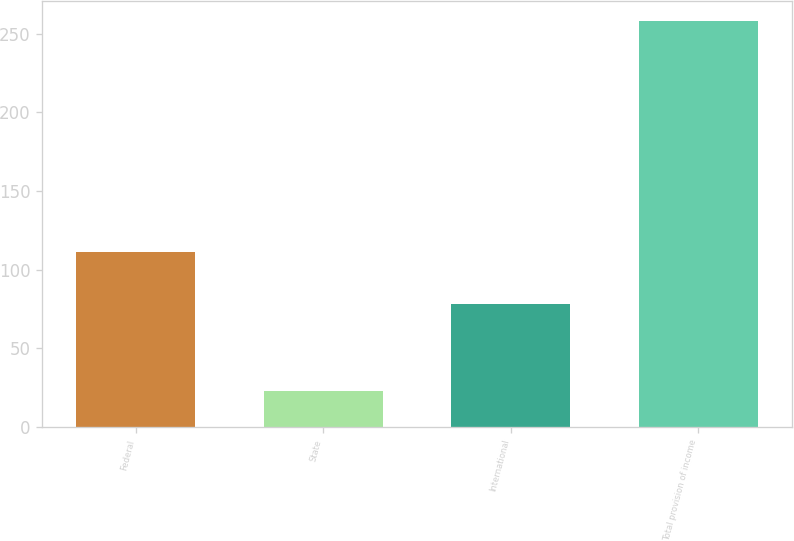Convert chart. <chart><loc_0><loc_0><loc_500><loc_500><bar_chart><fcel>Federal<fcel>State<fcel>International<fcel>Total provision of income<nl><fcel>111<fcel>23<fcel>78<fcel>258<nl></chart> 